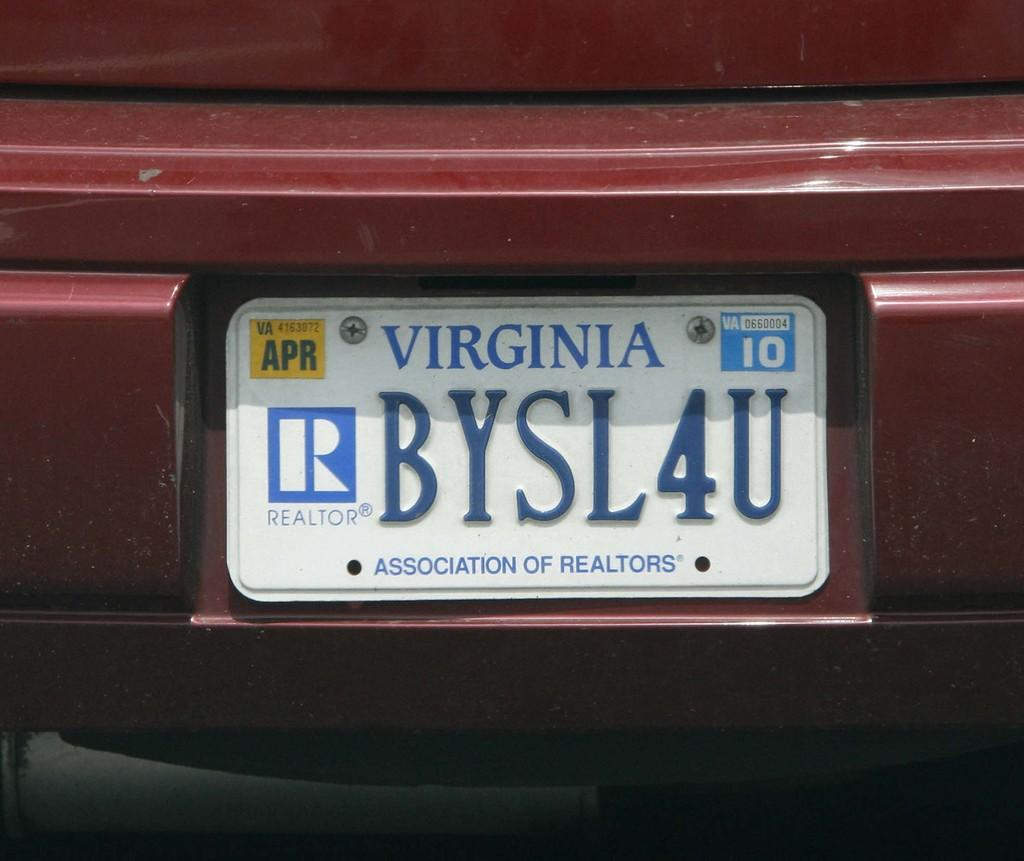<image>
Present a compact description of the photo's key features. A Virginia license plate that says "BYSL4U" on it and notes that the driver is a realtor. 